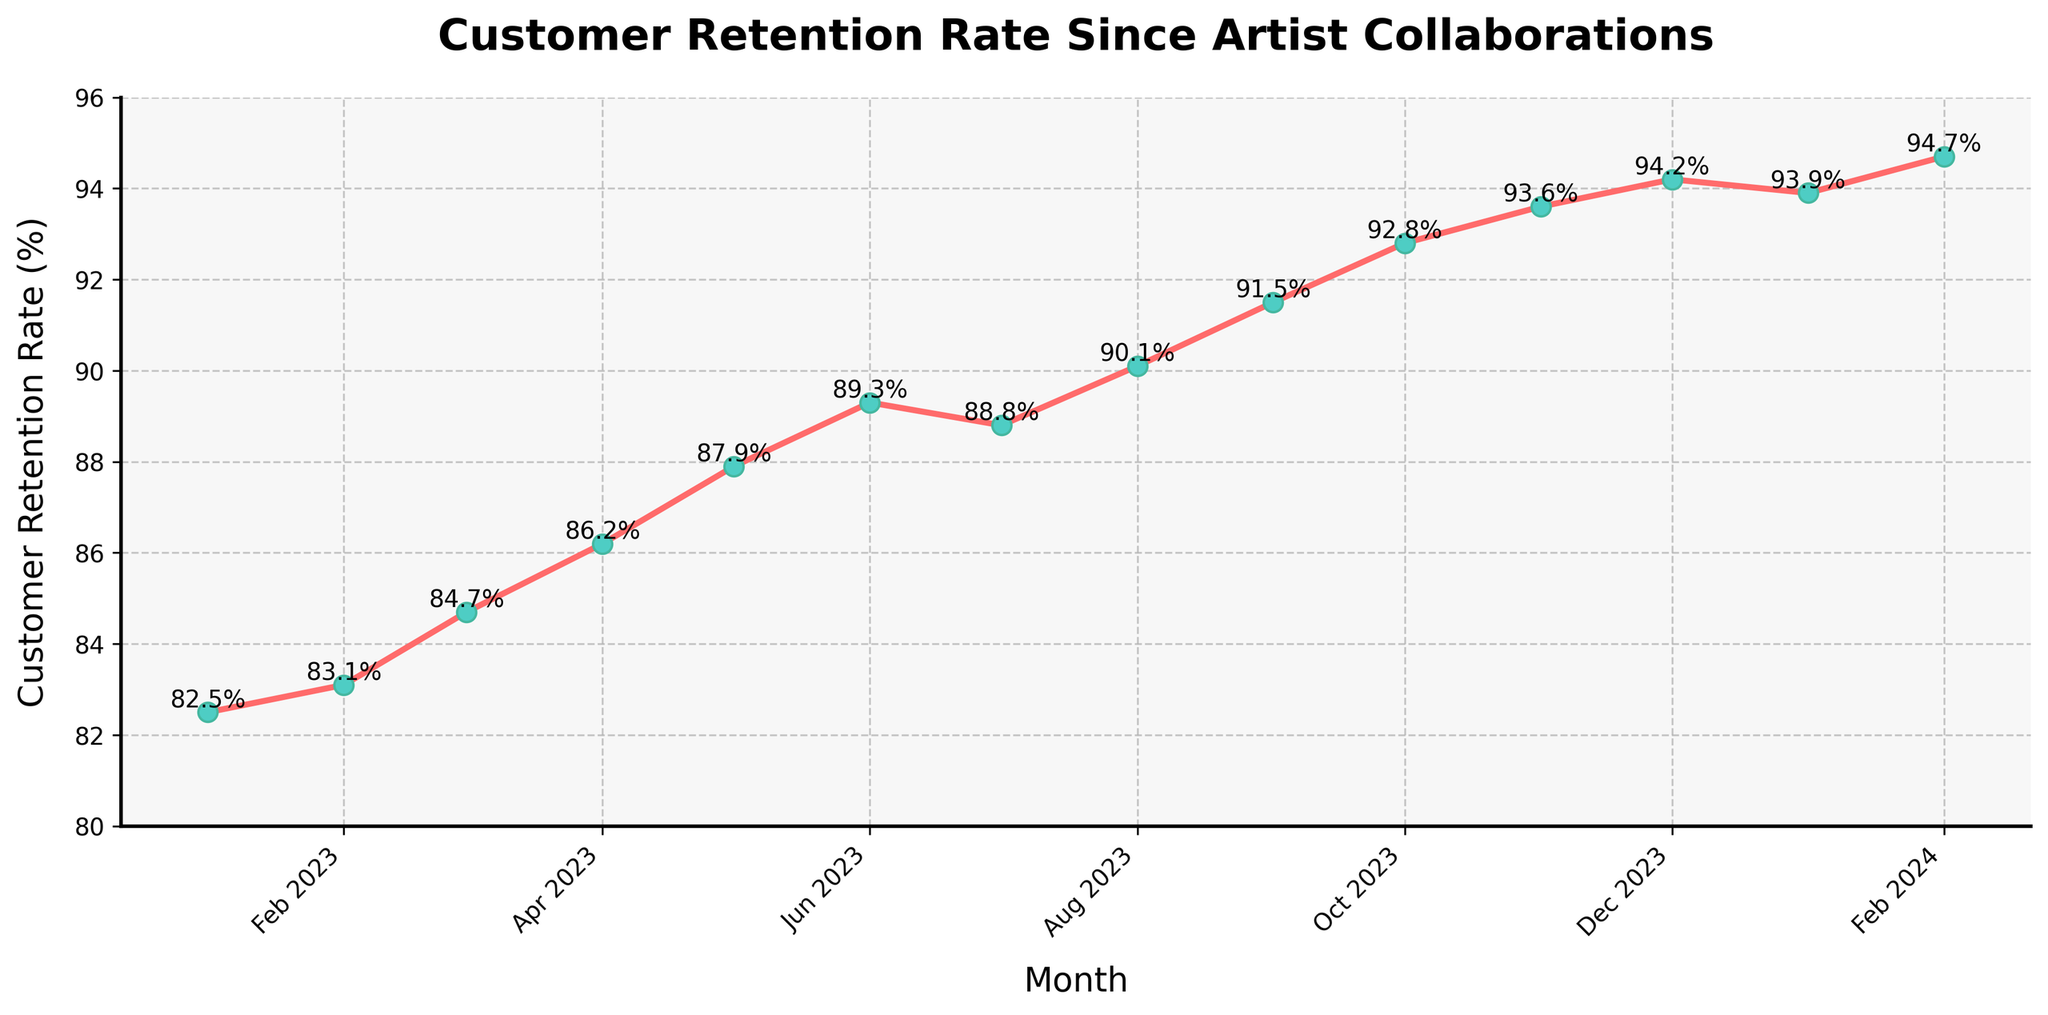How did the customer retention rate change from January 2023 to December 2023? In January 2023, the customer retention rate was 82.5%. By December 2023, it had increased to 94.2%. The change is 94.2% - 82.5%.
Answer: 11.7% Which month had the highest customer retention rate in the given data? The highest customer retention rate in the given data is 94.7% in February 2024.
Answer: February 2024 What was the customer retention rate in July 2023? Locate July 2023 on the x-axis and observe the corresponding point on the y-axis which shows the customer retention rate of 88.8%.
Answer: 88.8% In which month did the customer retention rate first surpass 90%? The customer retention rate first surpassed 90% in August 2023, where it reached 90.1%.
Answer: August 2023 By how much did the customer retention rate increase from June 2023 to August 2023? The customer retention rate in June 2023 was 89.3%, and in August 2023, it was 90.1%. The increase is 90.1% - 89.3%.
Answer: 0.8% Compare the customer retention rate between January 2023 and January 2024. Was there an increase or decrease, and by how much? The customer retention rate in January 2023 was 82.5%, and in January 2024, it was 93.9%. The retention rate increased by 93.9% - 82.5%.
Answer: 11.4% What's the average customer retention rate from January 2023 to June 2023? Sum the retention rates from January 2023 to June 2023: 82.5 + 83.1 + 84.7 + 86.2 + 87.9 + 89.3 = 513.7. Divide by the number of months (6).
Answer: 85.6% Between which two consecutive months was the largest increase in customer retention rate observed? Calculate the difference for each consecutive pair of months and identify the largest. The largest increase is between Dec 2023 (94.2) and Nov 2023 (93.6), where the difference is 94.2 - 93.6 = 0.6.
Answer: November 2023 and December 2023 What is the trend in the customer retention rate observed in the data? Observing the line plot, the customer retention rate shows a general upward trend from January 2023 to February 2024.
Answer: Upward trend 